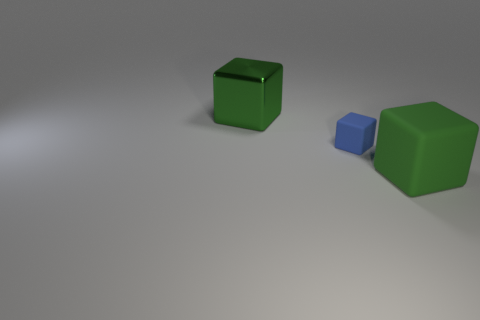Can you talk about the lighting and shadows in the scene? Certainly! In the image, we observe a diffused lighting setup that casts soft shadows to the objects' right sides. This diffused light creates a subtle gradient on the surface and appears to emulate an overcast day or a studio environment with a large, soft light source. The shadows suggest a single main light source and contribute to the three-dimensional appearance of the objects. 